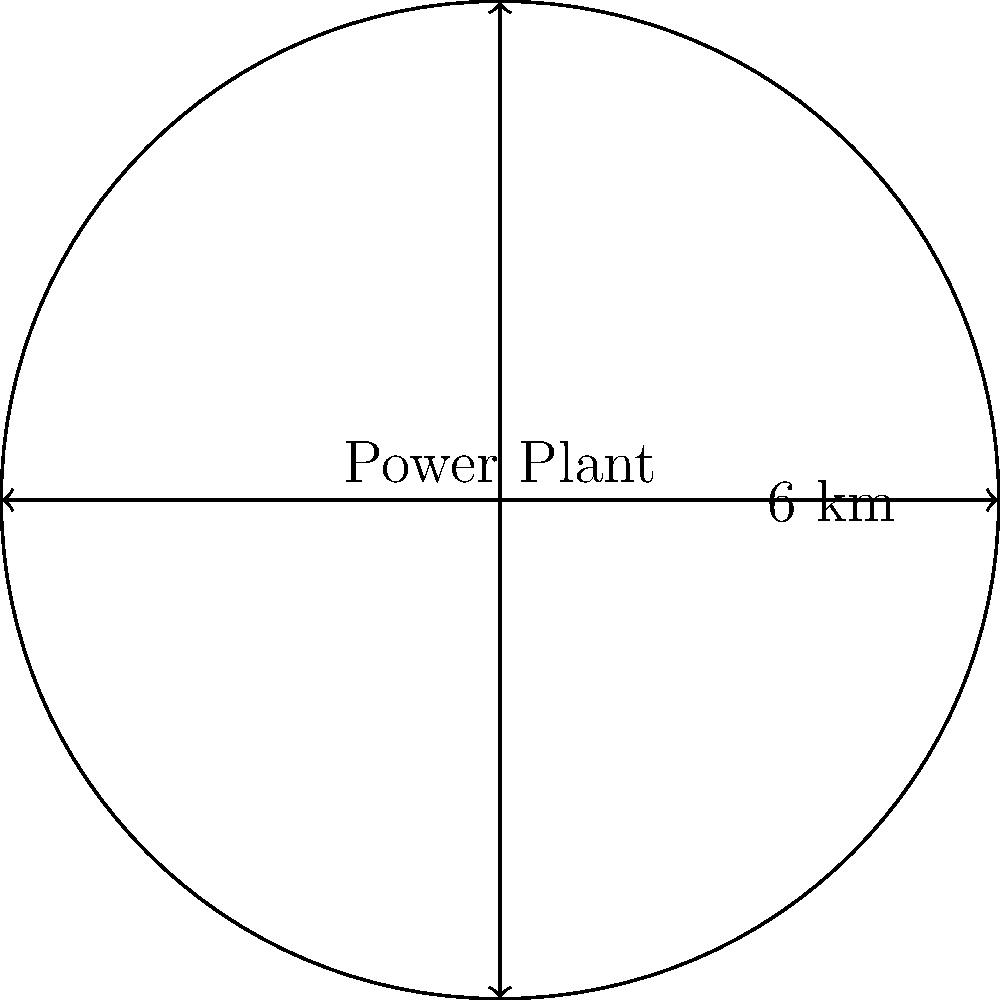A coal-fired power plant emits pollutants that affect the surrounding area in a circular pattern. The radius of this affected area is 6 km. Calculate the total area impacted by the power plant's emissions. How would doubling the radius affect the impacted area? To solve this problem, we'll follow these steps:

1. Calculate the area of the circular region:
   The formula for the area of a circle is $A = \pi r^2$, where $r$ is the radius.
   $A = \pi \cdot (6 \text{ km})^2 = 36\pi \text{ km}^2 \approx 113.10 \text{ km}^2$

2. Consider doubling the radius:
   If we double the radius to 12 km, the new area would be:
   $A_{new} = \pi \cdot (12 \text{ km})^2 = 144\pi \text{ km}^2 \approx 452.39 \text{ km}^2$

3. Compare the two areas:
   $452.39 \text{ km}^2 / 113.10 \text{ km}^2 = 4$

Therefore, doubling the radius increases the affected area by a factor of 4.

This relationship can be explained mathematically:
$(2r)^2 = 4r^2$

So, when we double the radius, we're actually quadrupling the area affected by the power plant's emissions.
Answer: 113.10 km²; quadruples the affected area 